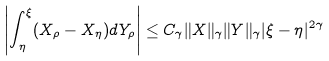<formula> <loc_0><loc_0><loc_500><loc_500>\left | \int _ { \eta } ^ { \xi } ( X _ { \rho } - X _ { \eta } ) d Y _ { \rho } \right | \leq C _ { \gamma } \| X \| _ { \gamma } \| Y \| _ { \gamma } | \xi - \eta | ^ { 2 \gamma }</formula> 